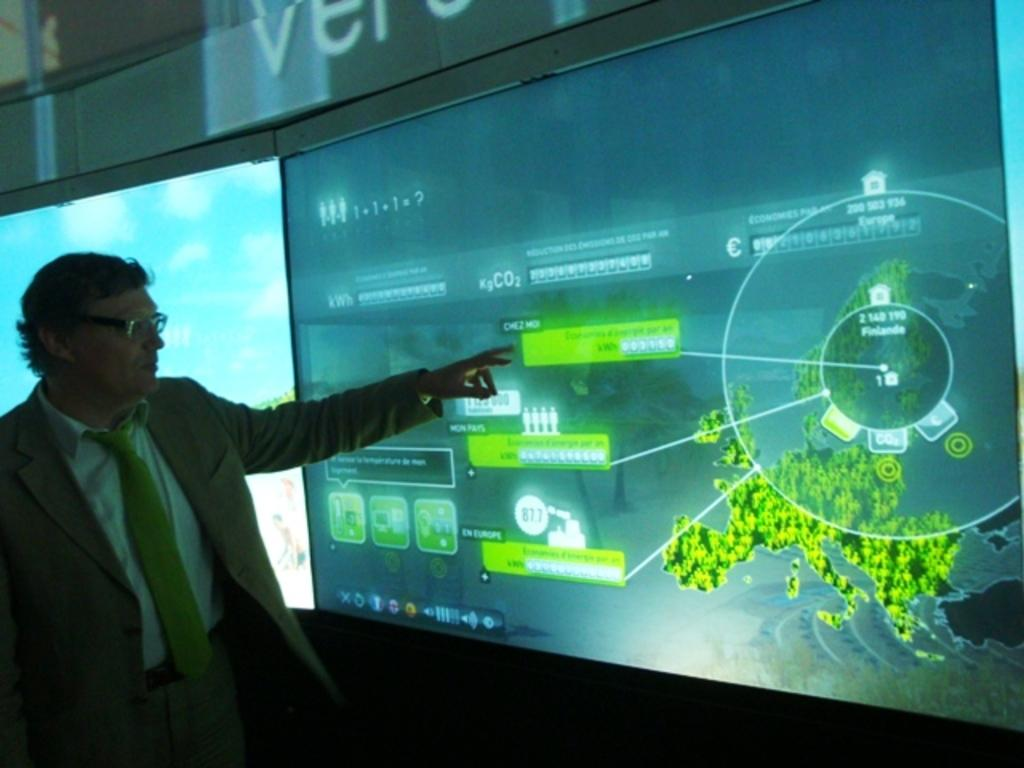<image>
Create a compact narrative representing the image presented. A man points at a map of Europe which has a number 2 visible on it. 